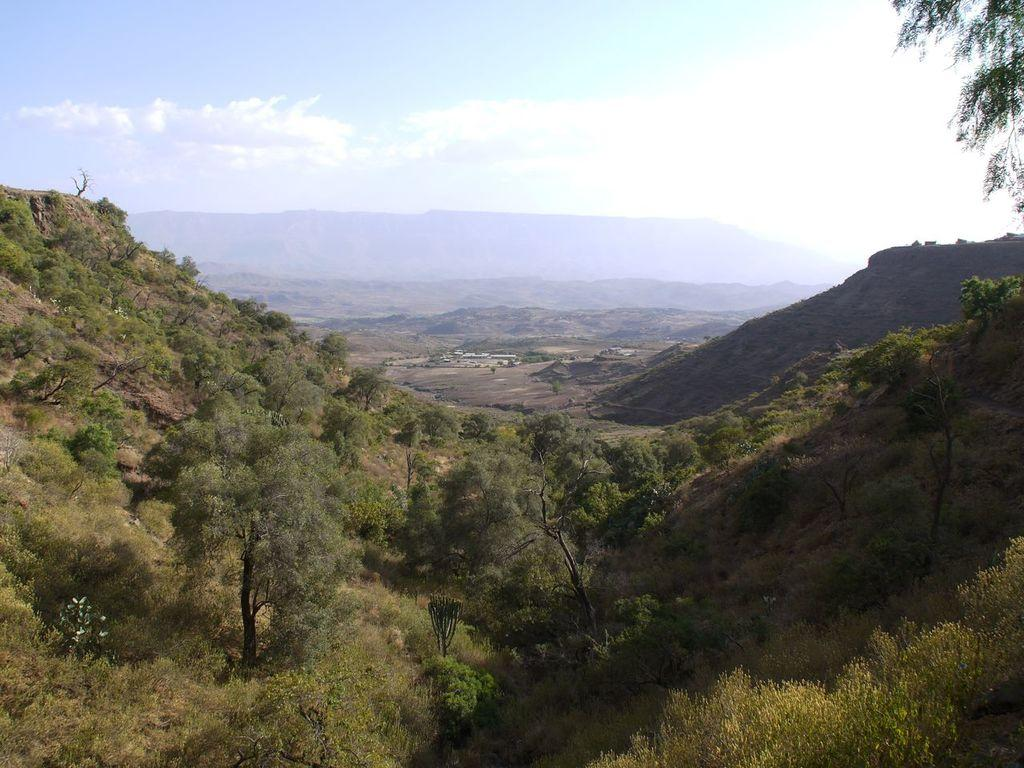What can be seen in the sky in the image? The sky with clouds is visible in the image. What type of natural features are present in the image? There are hills in the image. What type of man-made structures are present in the image? There are buildings in the image. What type of surface is visible in the image? The ground is visible in the image. What type of vegetation is present in the image? Trees are present in the image. Where is the bag placed in the image? There is no bag present in the image. What type of current can be seen flowing through the image? There is no current visible in the image; it is a landscape scene with hills, buildings, and trees. 